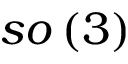Convert formula to latex. <formula><loc_0><loc_0><loc_500><loc_500>s o \left ( 3 \right )</formula> 